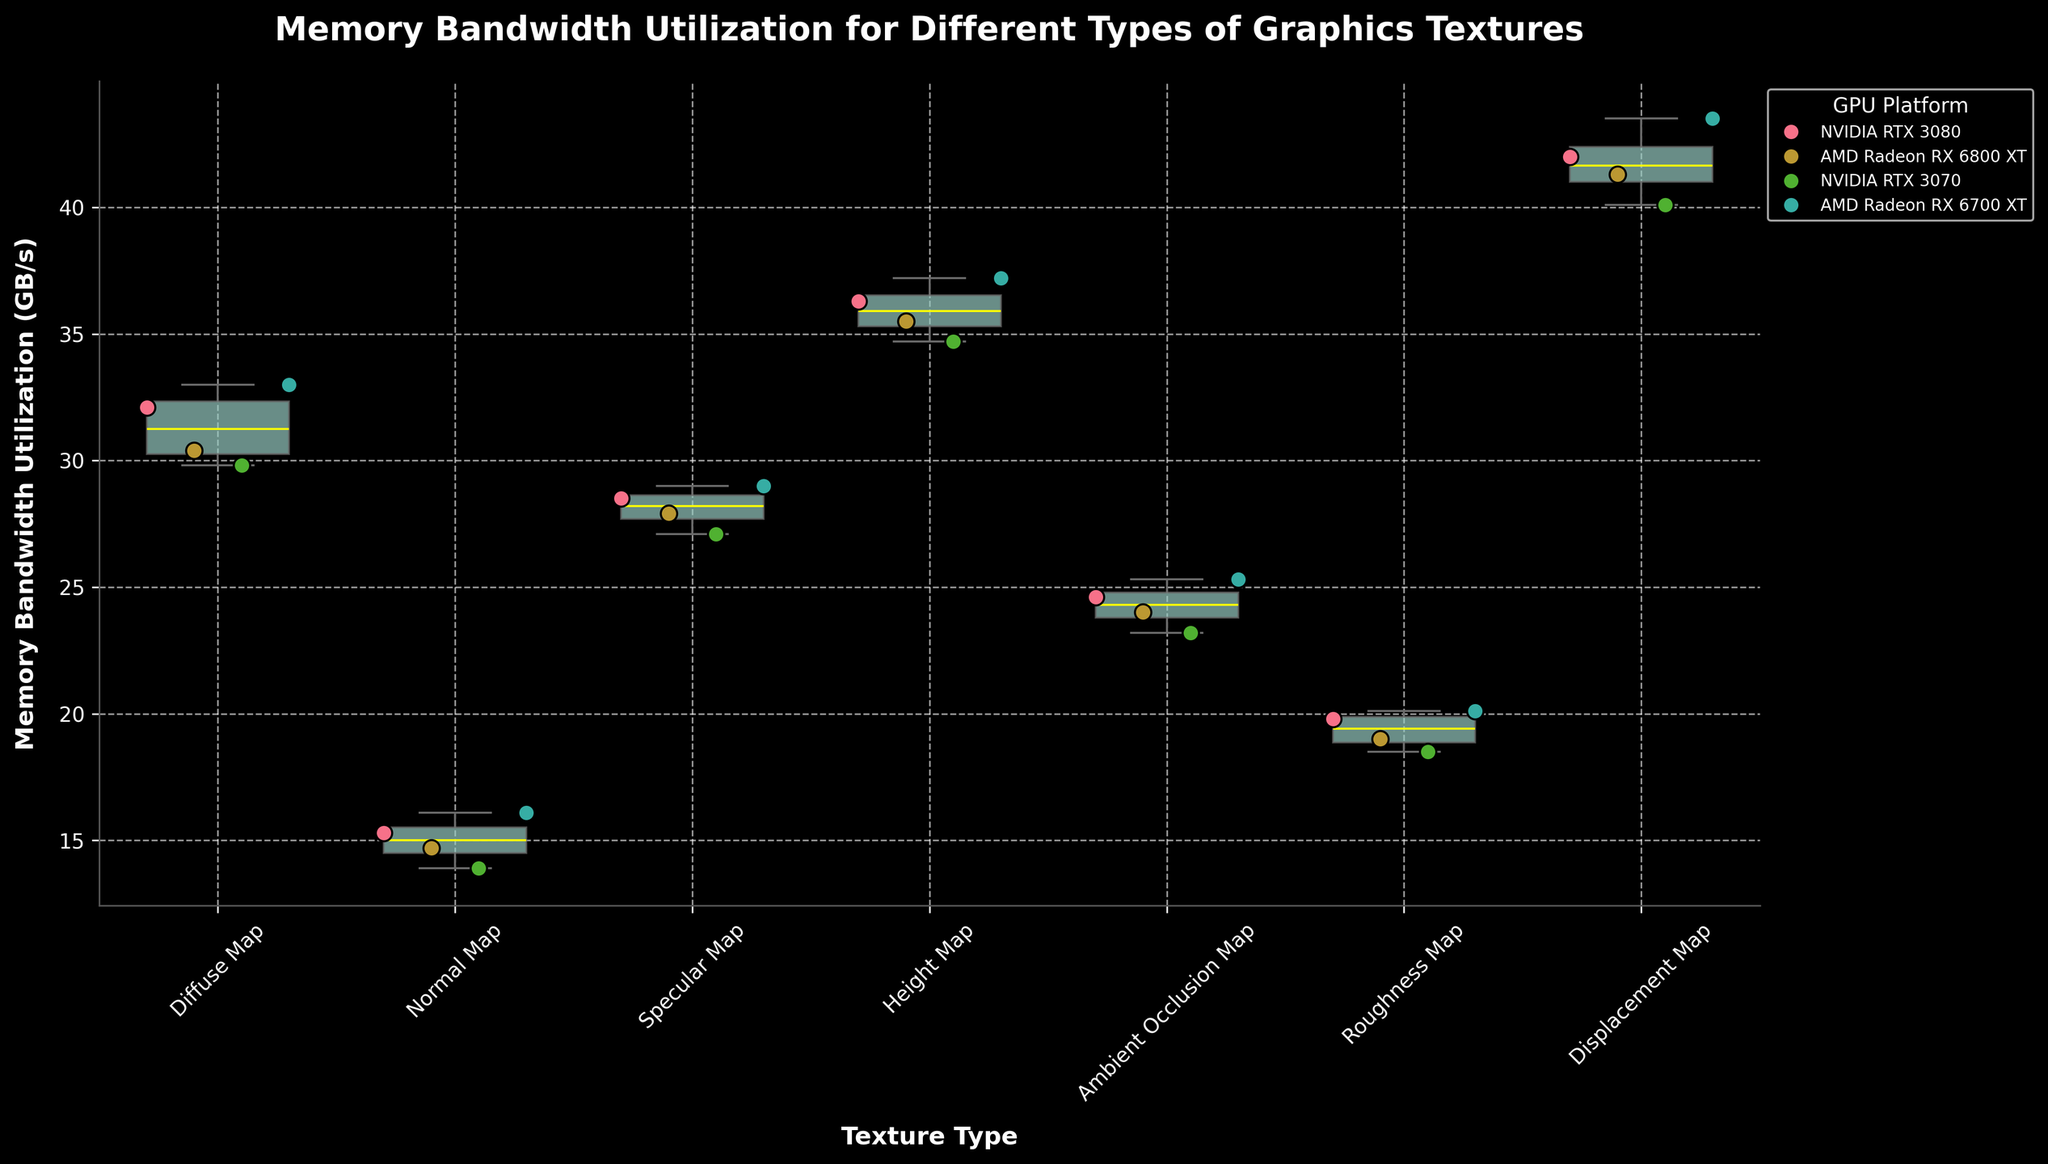Which texture type has the highest median memory bandwidth utilization? The box plots show the median value as a line inside each box. The Height Map has the highest median memory bandwidth utilization among the textures.
Answer: Height Map What's the range of memory bandwidth utilization for the Roughness Map texture type? The range is the difference between the highest and lowest values within the whiskers for the Roughness Map. The Roughness Map ranges from about 18.5 GB/s to 20.1 GB/s.
Answer: 1.6 GB/s How does the utilization of the Diffuse Map compare across different GPU platforms? By observing the scatter points for the Diffuse Map, the utilization values are approximately 32.1, 30.4, 29.8, and 33.0 GB/s for the NVIDIA RTX 3080, AMD Radeon RX 6800 XT, NVIDIA RTX 3070, and AMD Radeon RX 6700 XT respectively.
Answer: RTX 3080 > RX 6700 XT > RX 6800 XT > RTX 3070 Are there any outliers in the memory bandwidth utilization for the Normal Map texture type? Outliers are typically shown as dots outside the whiskers in a box plot. There are no outliers present for the Normal Map texture type.
Answer: No Which GPU platform has the highest memory bandwidth utilization for the Displacement Map texture type? By looking at the scatter points for the Displacement Map, the highest value is for the AMD Radeon RX 6700 XT with a utilization of 43.5 GB/s.
Answer: AMD Radeon RX 6700 XT What's the difference in median memory bandwidth utilization between Diffuse Map and Ambient Occlusion Map? To find the difference, we look at the median lines in the box plots for both textures. Diffuse Map's median is around 31.2 GB/s, and Ambient Occlusion Map's median is around 24.7 GB/s. The difference is approximately 6.5 GB/s.
Answer: 6.5 GB/s Which texture type has the most consistent memory bandwidth utilization across the different GPU platforms? Consistency can be inferred by the spread of the values within a box plot. The Normal Map has the smallest interquartile range (IQR), indicating the most consistent utilization.
Answer: Normal Map Do any textures have a considerable difference in memory bandwidth utilization between the highest and lowest GPU platforms? If so, which ones? By comparing the spread within each texture type, the Displacement Map shows a considerable difference. The highest value (43.5 GB/s) and the lowest value (40.1 GB/s) indicate a difference of 3.4 GB/s.
Answer: Displacement Map Is there any texture type where AMD GPUs uniformly outperform NVIDIA GPUs in terms of memory bandwidth utilization? By examining the scatter points for each GPU within each texture type, there is no texture where AMD GPUs uniformly outperform NVIDIA GPUs.
Answer: No What's the average memory bandwidth utilization for the Specular Map across all GPUs? We sum the memory bandwidth utilization values for Specular Map (28.5, 27.9, 27.1, 29.0) and divide by the number of data points (4). The sum is 112.5, so the average is 112.5/4 = 28.125 GB/s.
Answer: 28.125 GB/s 